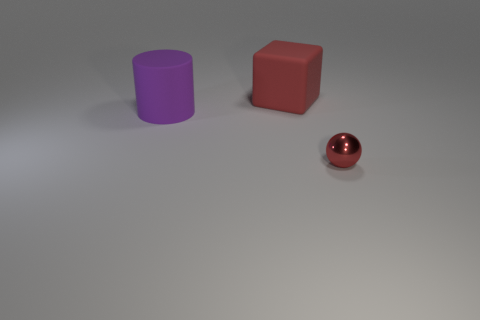Add 1 large cubes. How many objects exist? 4 Subtract all cylinders. How many objects are left? 2 Add 2 cylinders. How many cylinders are left? 3 Add 1 red metal spheres. How many red metal spheres exist? 2 Subtract 0 green cylinders. How many objects are left? 3 Subtract all large red rubber things. Subtract all tiny red metal balls. How many objects are left? 1 